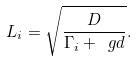Convert formula to latex. <formula><loc_0><loc_0><loc_500><loc_500>L _ { i } = \sqrt { \frac { D } { \Gamma _ { i } + \ g d } } .</formula> 